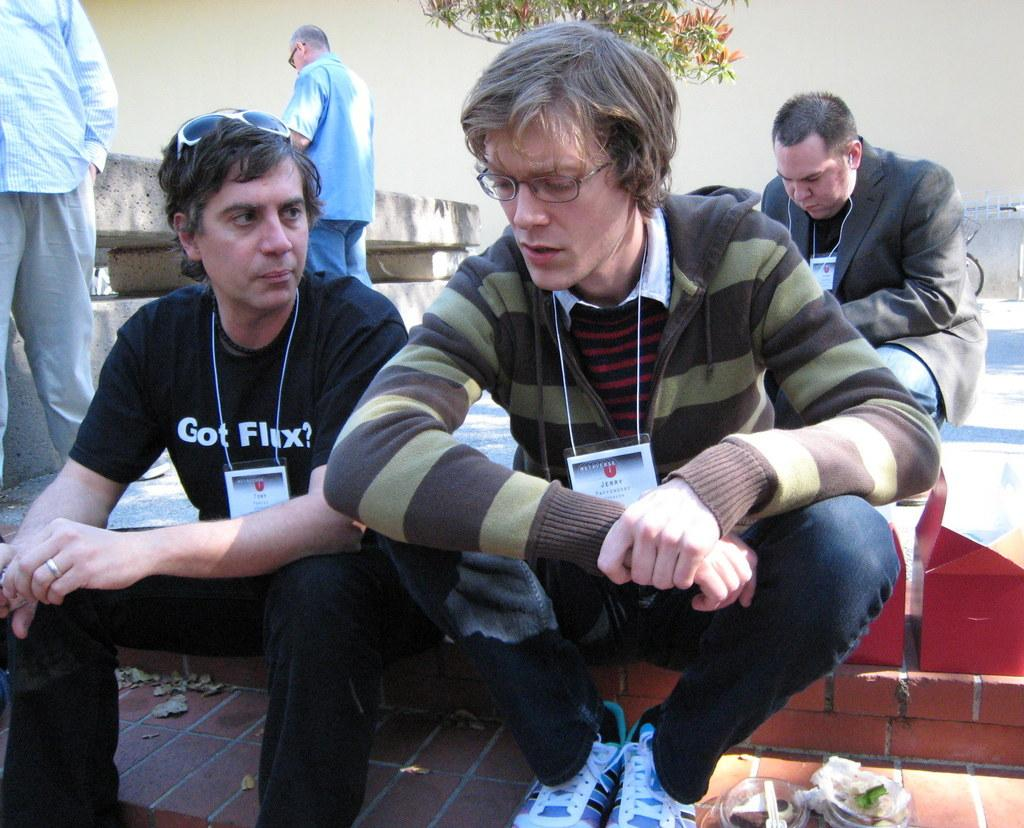What are the people in the image doing? The people in the image are sitting. Are there any other people visible in the image besides those sitting? Yes, there are two persons standing at the left side of the image. What type of pizzas can be seen in the image? There are no pizzas present in the image. What is the smell like in the image? The image does not convey any information about smells, so it cannot be determined from the image. 